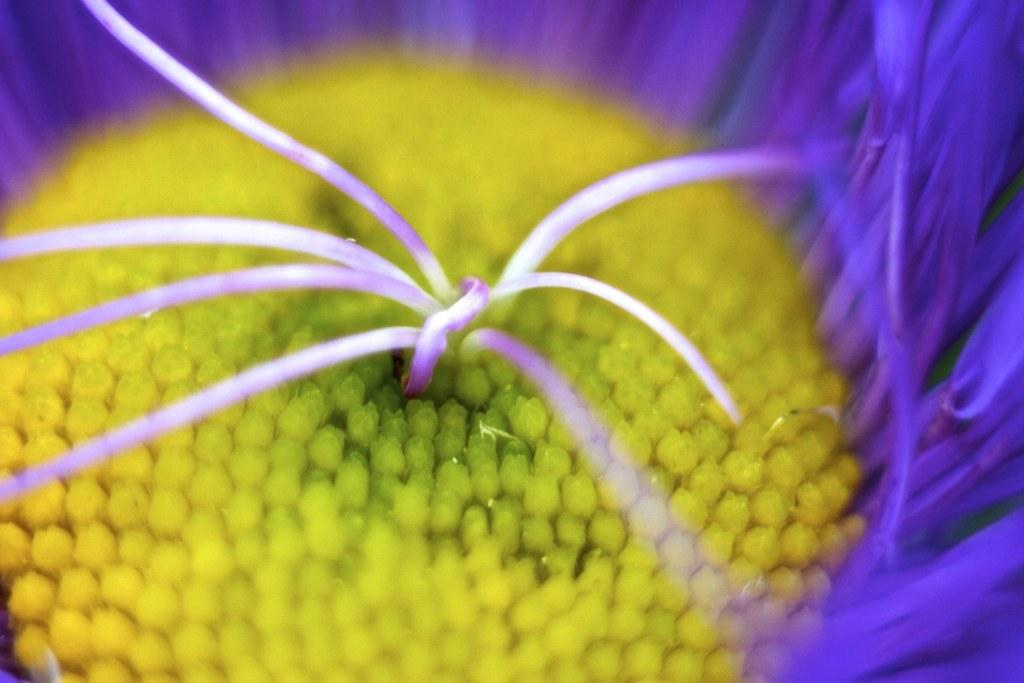What is the main subject of the image? The main subject of the image is a flower. What color are the petals of the flower? The petals of the flower have a violet color. How many steam engines are present in the image? There are no steam engines present in the image; it features a flower with violet petals. What type of shame is depicted in the image? There is no shame depicted in the image; it features a flower with violet petals. 